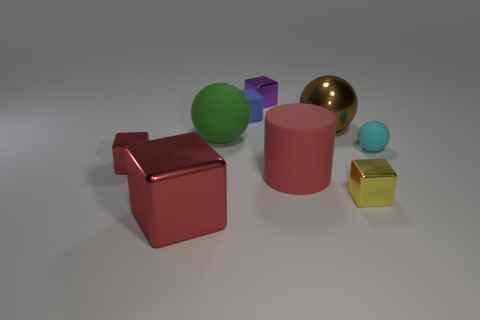Subtract all small blue matte cubes. How many cubes are left? 4 Subtract all cyan balls. How many balls are left? 2 Subtract all cylinders. How many objects are left? 8 Subtract 2 spheres. How many spheres are left? 1 Subtract all gray balls. How many red cubes are left? 2 Add 1 green rubber things. How many green rubber things are left? 2 Add 1 small red rubber things. How many small red rubber things exist? 1 Subtract 0 yellow spheres. How many objects are left? 9 Subtract all gray spheres. Subtract all gray cylinders. How many spheres are left? 3 Subtract all red objects. Subtract all tiny metal objects. How many objects are left? 3 